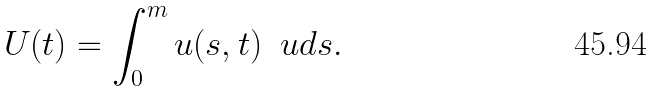<formula> <loc_0><loc_0><loc_500><loc_500>U ( t ) = \int _ { 0 } ^ { m } u ( s , t ) \, \ u d s .</formula> 